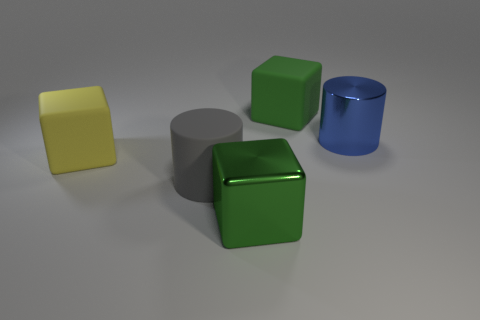There is a rubber block that is the same color as the shiny block; what size is it? The rubber block that shares the same green color as the shiny block appears to be medium-sized in comparison with the surrounding objects. 